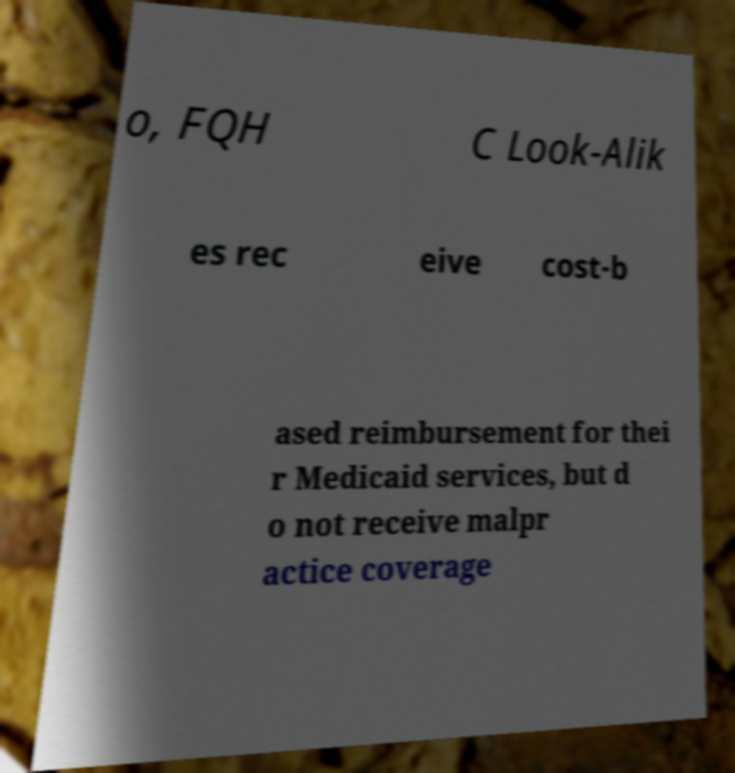For documentation purposes, I need the text within this image transcribed. Could you provide that? o, FQH C Look-Alik es rec eive cost-b ased reimbursement for thei r Medicaid services, but d o not receive malpr actice coverage 